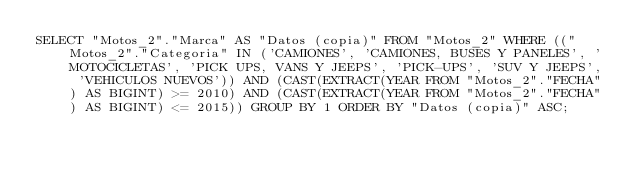<code> <loc_0><loc_0><loc_500><loc_500><_SQL_>SELECT "Motos_2"."Marca" AS "Datos (copia)" FROM "Motos_2" WHERE (("Motos_2"."Categoria" IN ('CAMIONES', 'CAMIONES, BUSES Y PANELES', 'MOTOCICLETAS', 'PICK UPS, VANS Y JEEPS', 'PICK-UPS', 'SUV Y JEEPS', 'VEHICULOS NUEVOS')) AND (CAST(EXTRACT(YEAR FROM "Motos_2"."FECHA") AS BIGINT) >= 2010) AND (CAST(EXTRACT(YEAR FROM "Motos_2"."FECHA") AS BIGINT) <= 2015)) GROUP BY 1 ORDER BY "Datos (copia)" ASC;
</code> 